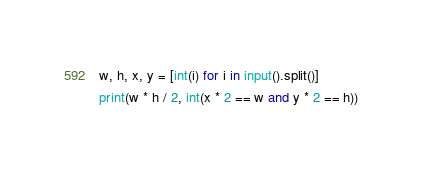<code> <loc_0><loc_0><loc_500><loc_500><_Python_>w, h, x, y = [int(i) for i in input().split()]
print(w * h / 2, int(x * 2 == w and y * 2 == h))</code> 